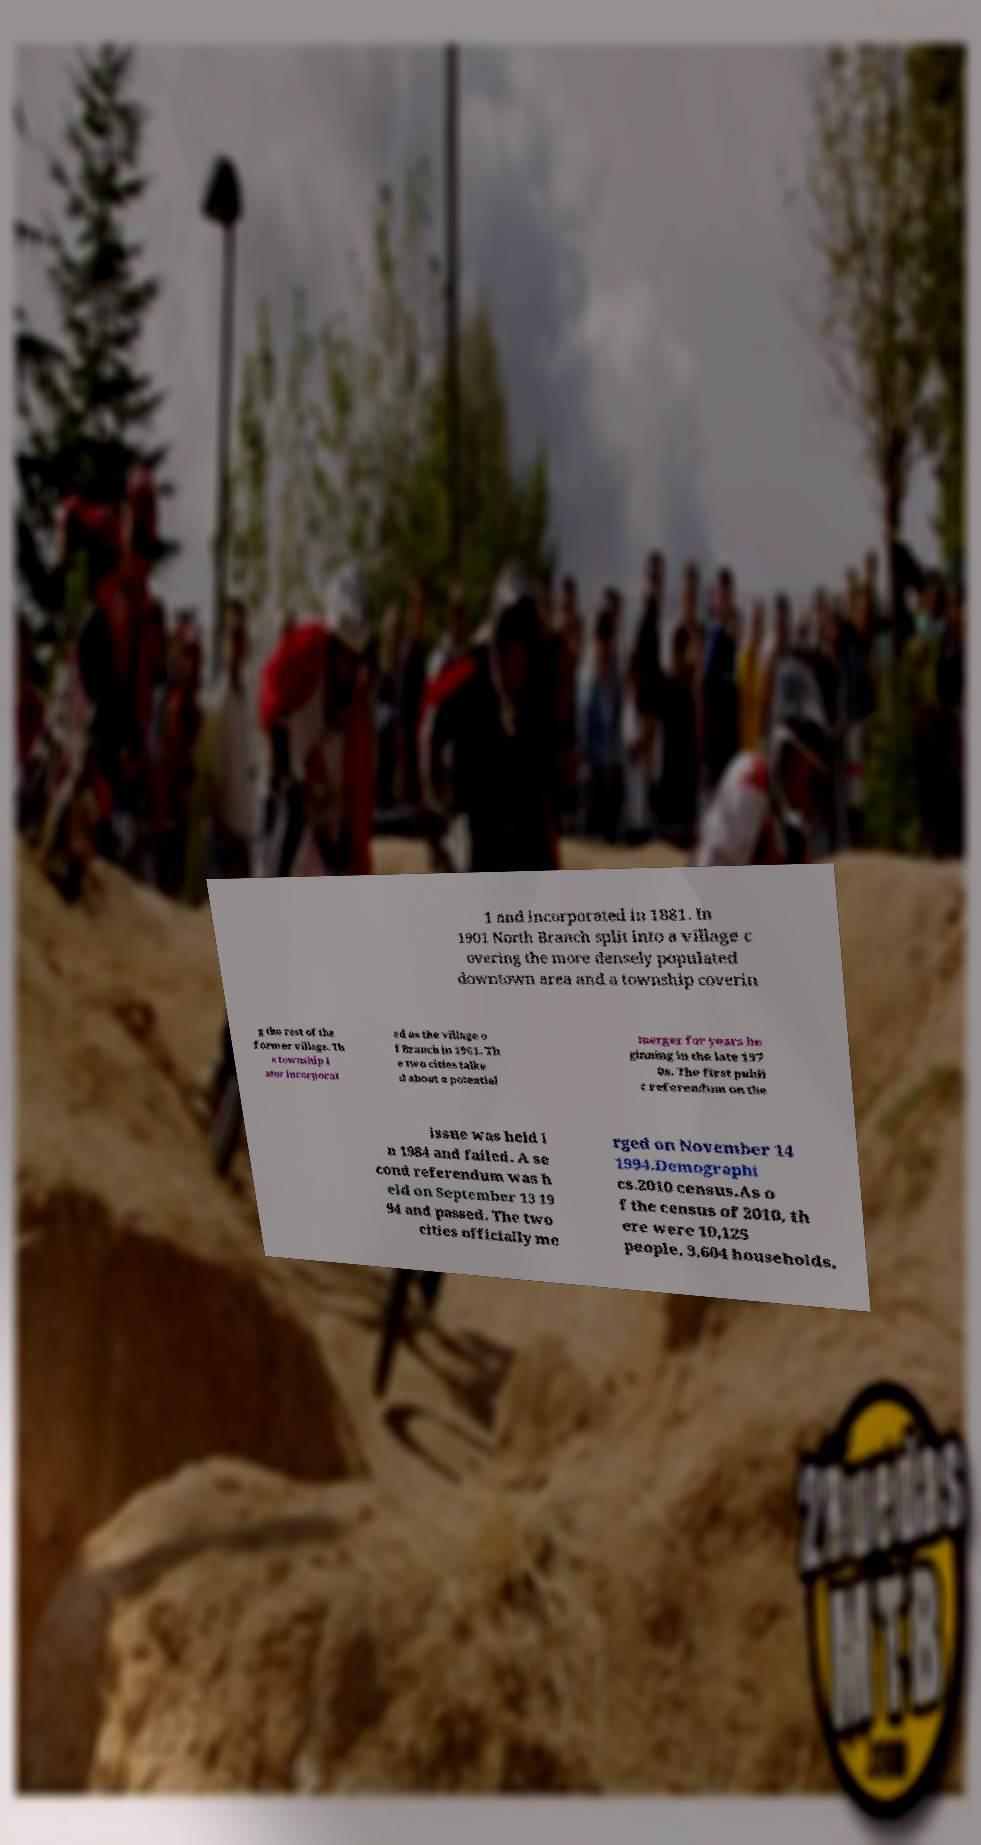For documentation purposes, I need the text within this image transcribed. Could you provide that? 1 and incorporated in 1881. In 1901 North Branch split into a village c overing the more densely populated downtown area and a township coverin g the rest of the former village. Th e township l ater incorporat ed as the village o f Branch in 1961. Th e two cities talke d about a potential merger for years be ginning in the late 197 0s. The first publi c referendum on the issue was held i n 1984 and failed. A se cond referendum was h eld on September 13 19 94 and passed. The two cities officially me rged on November 14 1994.Demographi cs.2010 census.As o f the census of 2010, th ere were 10,125 people, 3,604 households, 